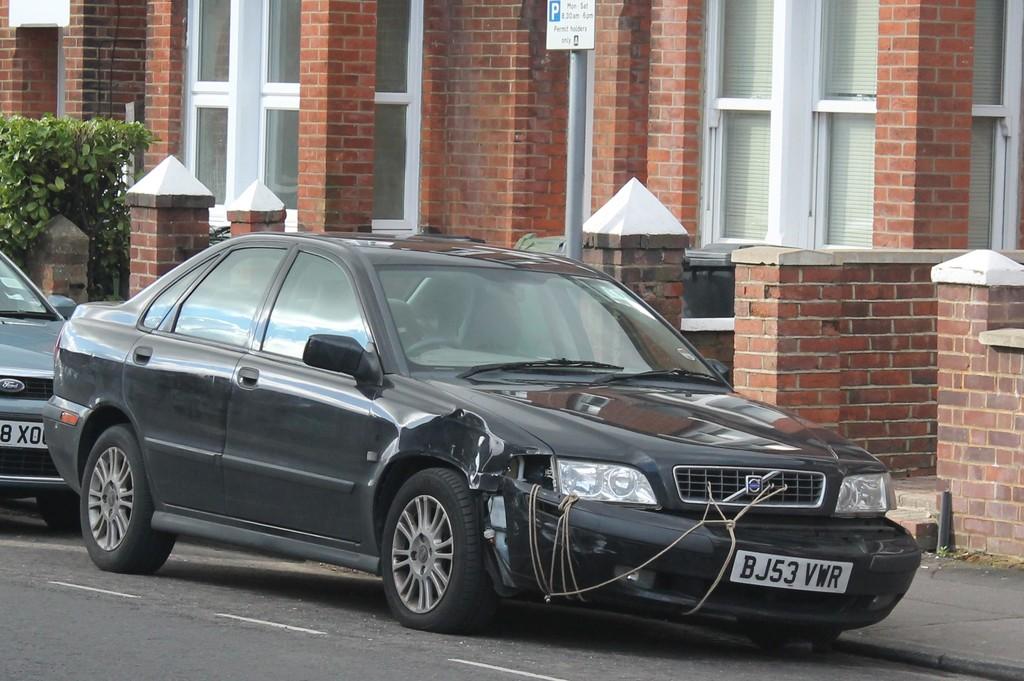What's the license plate say?
Your response must be concise. Bj53 vwr. What is the brand of the car behind the black car?
Offer a very short reply. Ford. 